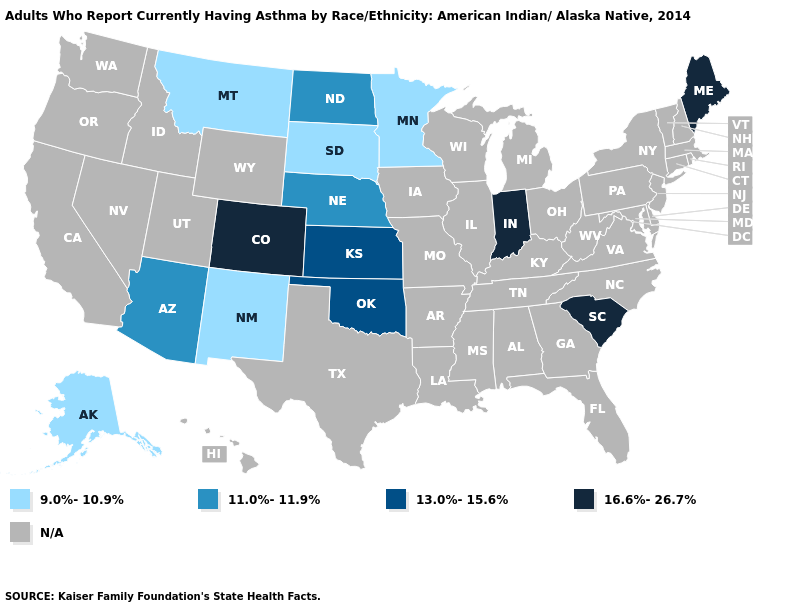Name the states that have a value in the range N/A?
Give a very brief answer. Alabama, Arkansas, California, Connecticut, Delaware, Florida, Georgia, Hawaii, Idaho, Illinois, Iowa, Kentucky, Louisiana, Maryland, Massachusetts, Michigan, Mississippi, Missouri, Nevada, New Hampshire, New Jersey, New York, North Carolina, Ohio, Oregon, Pennsylvania, Rhode Island, Tennessee, Texas, Utah, Vermont, Virginia, Washington, West Virginia, Wisconsin, Wyoming. What is the value of Maine?
Concise answer only. 16.6%-26.7%. Which states have the lowest value in the MidWest?
Short answer required. Minnesota, South Dakota. What is the lowest value in the USA?
Quick response, please. 9.0%-10.9%. Does the map have missing data?
Answer briefly. Yes. What is the lowest value in the USA?
Answer briefly. 9.0%-10.9%. Among the states that border Idaho , which have the lowest value?
Concise answer only. Montana. What is the highest value in the USA?
Short answer required. 16.6%-26.7%. Among the states that border Texas , does New Mexico have the highest value?
Write a very short answer. No. Which states have the lowest value in the MidWest?
Answer briefly. Minnesota, South Dakota. Which states have the lowest value in the USA?
Quick response, please. Alaska, Minnesota, Montana, New Mexico, South Dakota. 